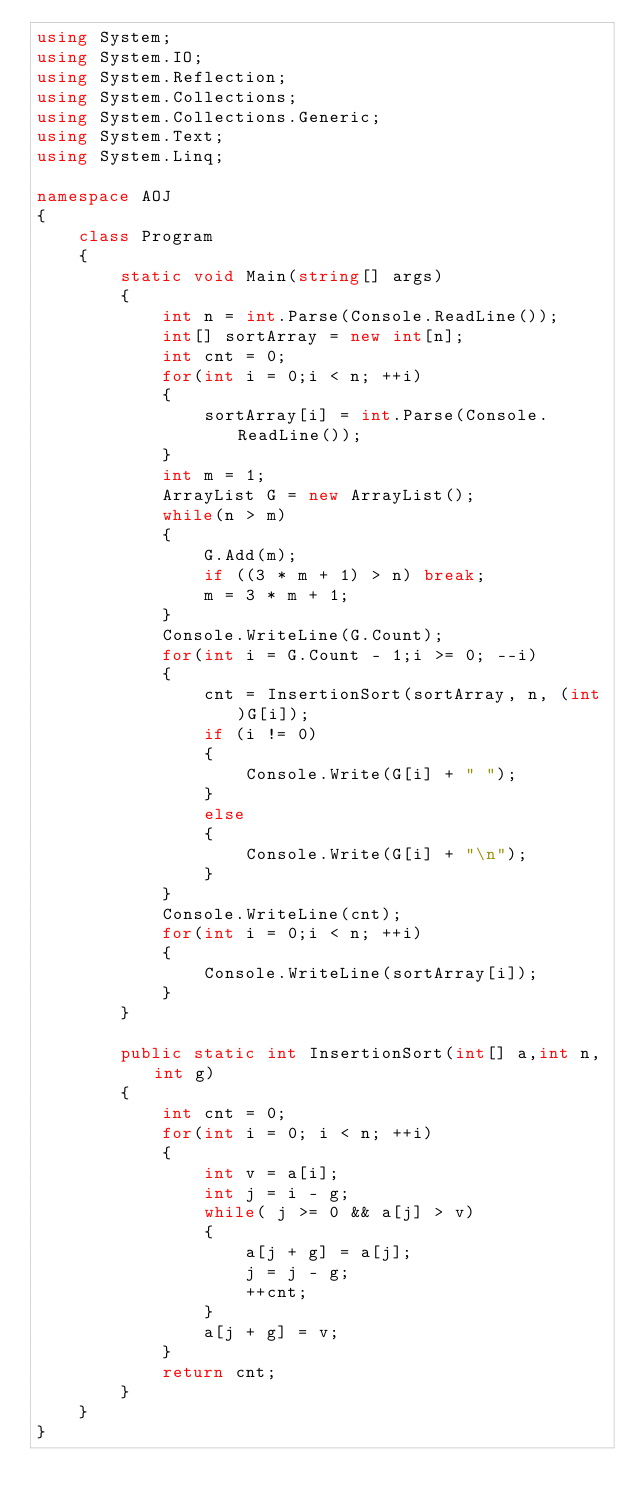<code> <loc_0><loc_0><loc_500><loc_500><_C#_>using System;
using System.IO;
using System.Reflection;
using System.Collections;
using System.Collections.Generic;
using System.Text;
using System.Linq;
   
namespace AOJ
{
    class Program
    {
        static void Main(string[] args)
        {
            int n = int.Parse(Console.ReadLine());
            int[] sortArray = new int[n];
            int cnt = 0;
            for(int i = 0;i < n; ++i)
            {
                sortArray[i] = int.Parse(Console.ReadLine());
            }
            int m = 1;
            ArrayList G = new ArrayList();
            while(n > m)
            {
                G.Add(m);
                if ((3 * m + 1) > n) break;
                m = 3 * m + 1;
            }
            Console.WriteLine(G.Count);
            for(int i = G.Count - 1;i >= 0; --i)
            {
                cnt = InsertionSort(sortArray, n, (int)G[i]);
                if (i != 0)
                {
                    Console.Write(G[i] + " ");
                }
                else
                {
                    Console.Write(G[i] + "\n");
                }
            }
            Console.WriteLine(cnt);
            for(int i = 0;i < n; ++i)
            {
                Console.WriteLine(sortArray[i]);
            }
        }
        
        public static int InsertionSort(int[] a,int n,int g)
        {
            int cnt = 0;
            for(int i = 0; i < n; ++i)
            {
                int v = a[i];
                int j = i - g;
                while( j >= 0 && a[j] > v)
                {
                    a[j + g] = a[j];
                    j = j - g;
                    ++cnt;
                }
                a[j + g] = v;
            }
            return cnt;
        }
    }
}</code> 